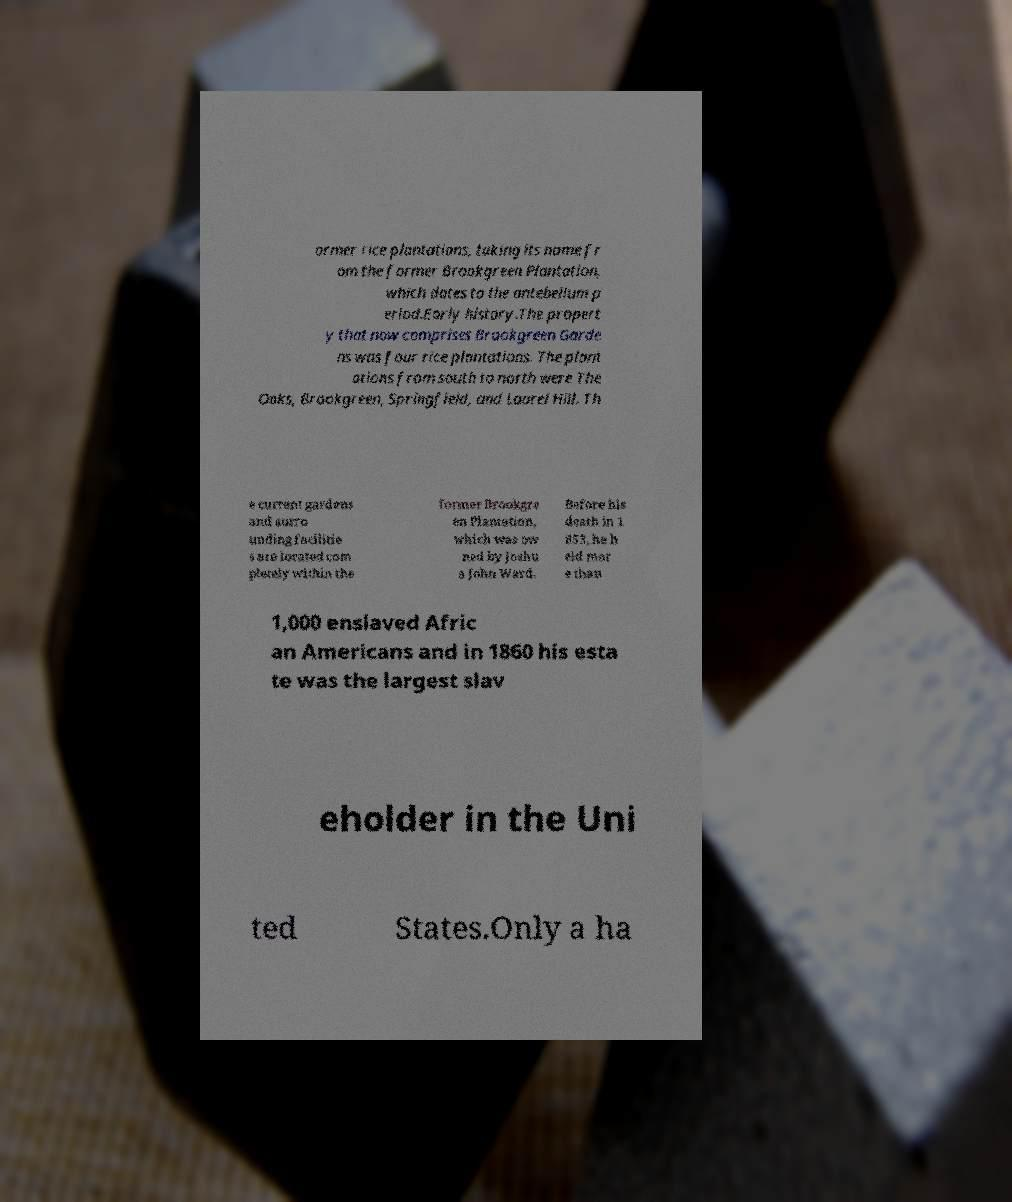Please identify and transcribe the text found in this image. ormer rice plantations, taking its name fr om the former Brookgreen Plantation, which dates to the antebellum p eriod.Early history.The propert y that now comprises Brookgreen Garde ns was four rice plantations. The plant ations from south to north were The Oaks, Brookgreen, Springfield, and Laurel Hill. Th e current gardens and surro unding facilitie s are located com pletely within the former Brookgre en Plantation, which was ow ned by Joshu a John Ward. Before his death in 1 853, he h eld mor e than 1,000 enslaved Afric an Americans and in 1860 his esta te was the largest slav eholder in the Uni ted States.Only a ha 